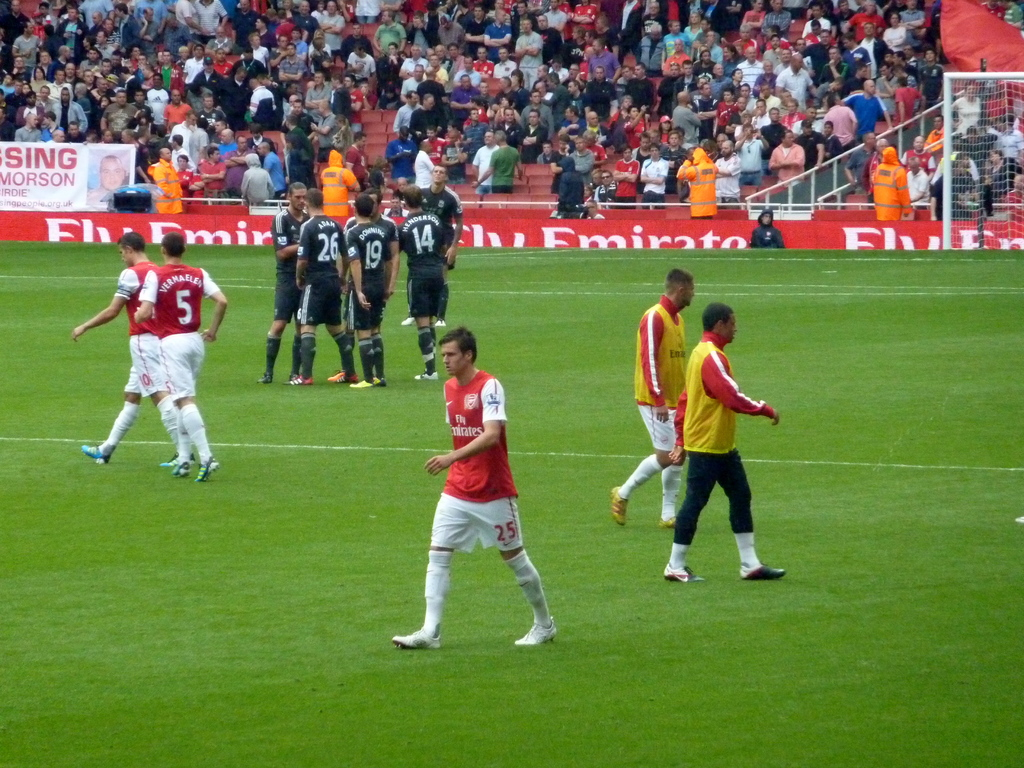What teams are playing in this soccer match? The image shows players in darker uniforms and others in red and white, which suggests that one team could be Arsenal FC, known for their red and white attire, playing against a team in dark jerseys. 